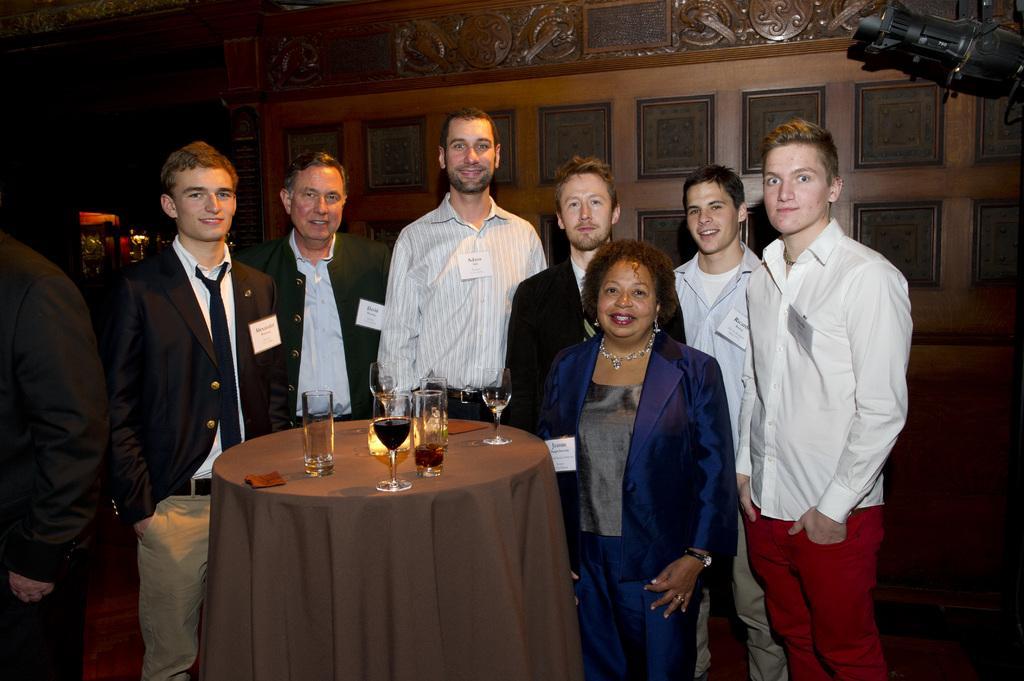Please provide a concise description of this image. There are many people standing around a table on which a wine glasses were placed. There are men and women in this group. In the background there is a wall. 